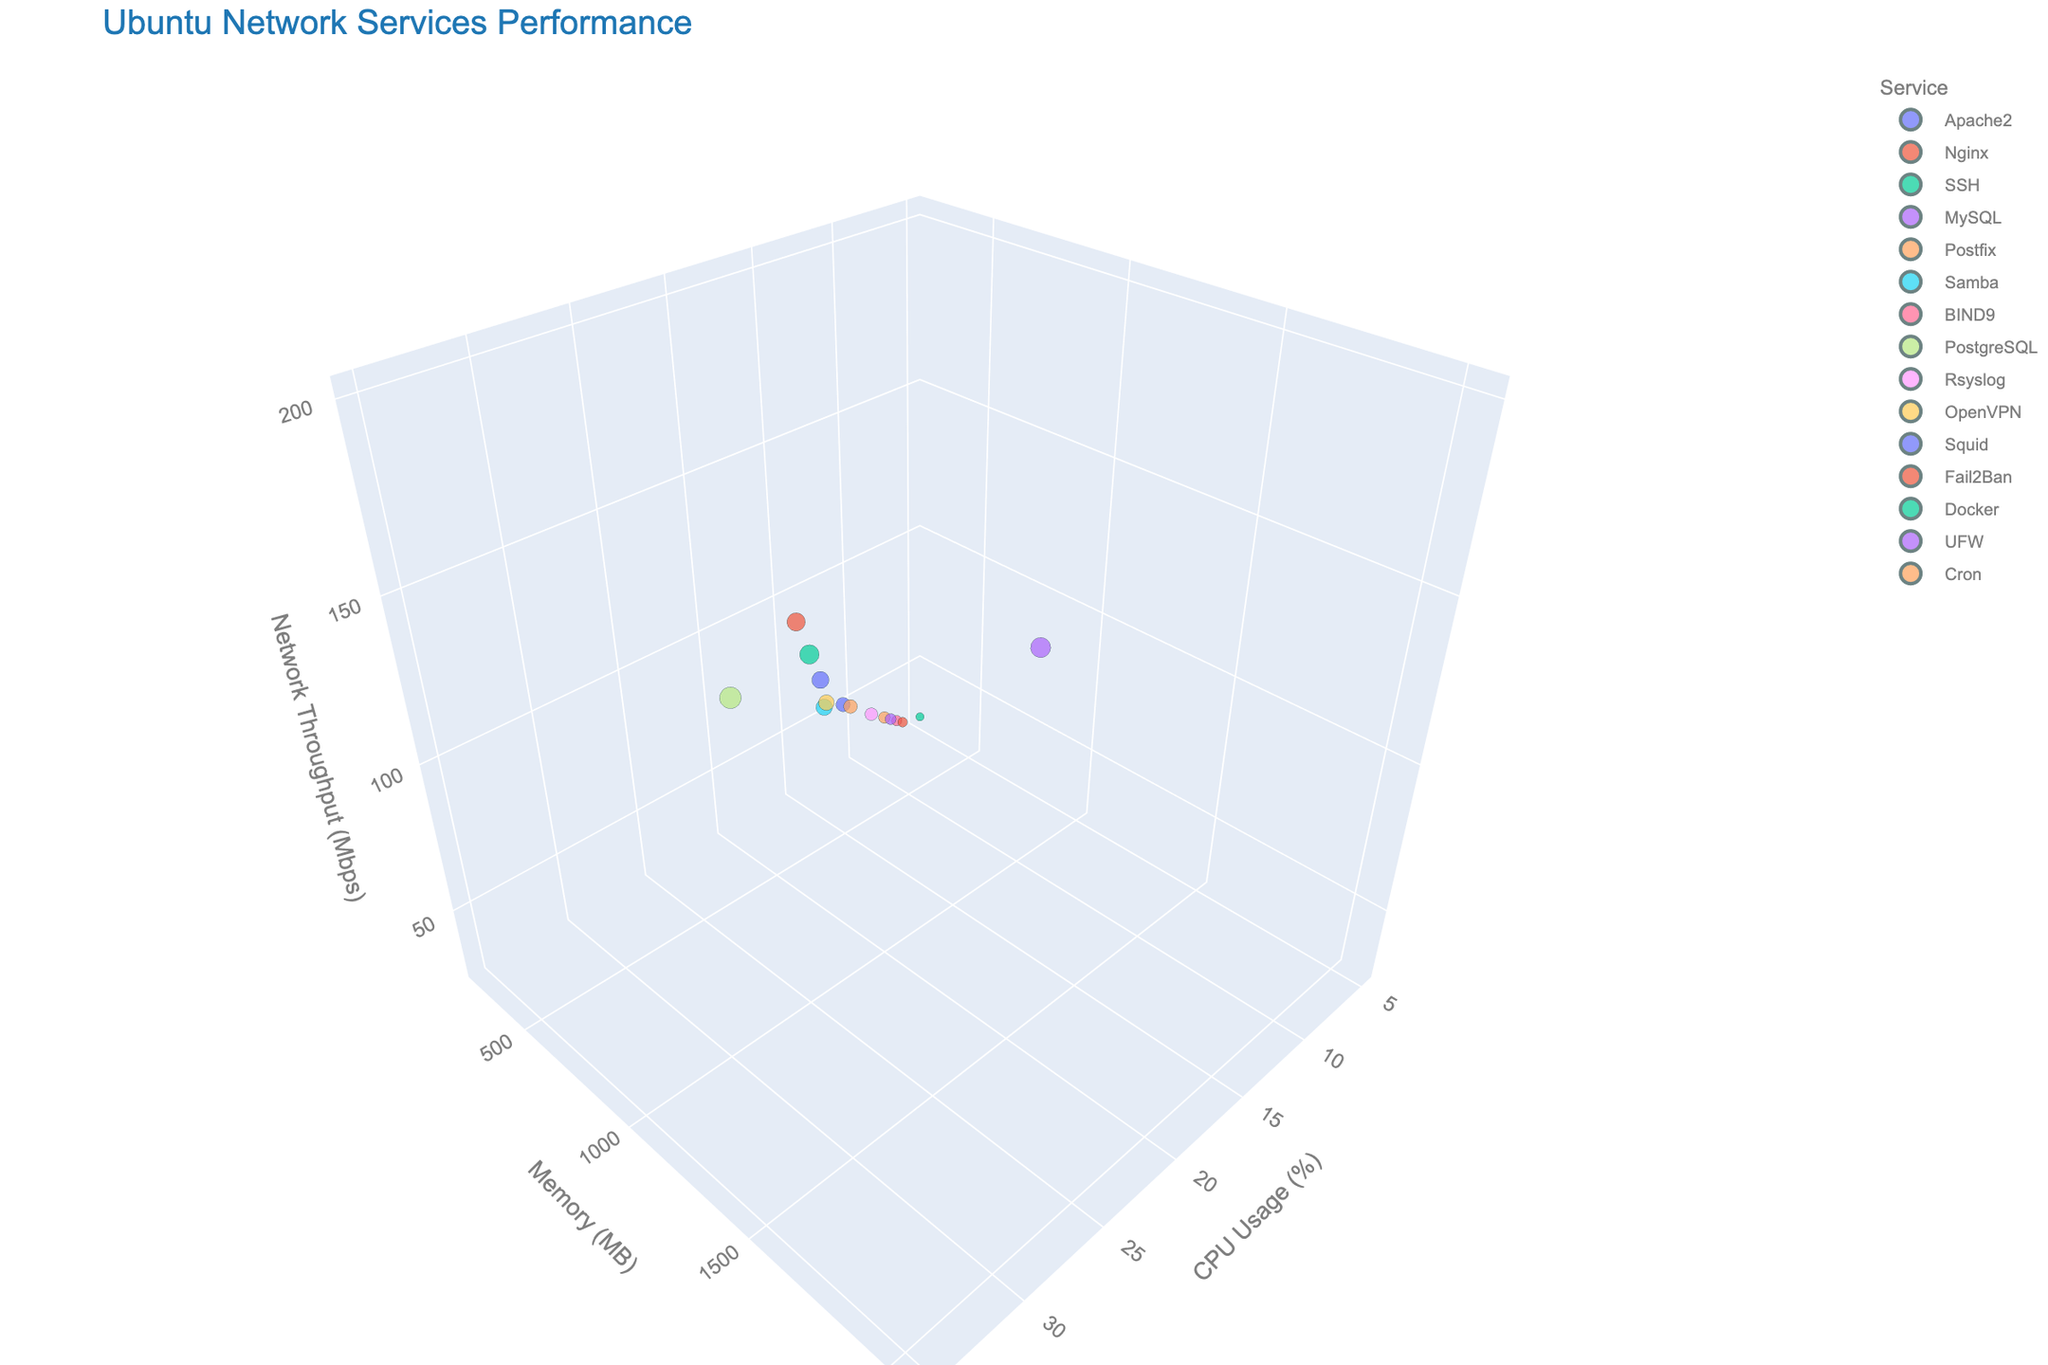How many different services are shown in the plot? By counting each unique service label in the data points, we find there are 15 different services represented in the plot.
Answer: 15 Which service has the highest CPU usage? By looking at the 'CPU Usage' axis, the highest value is 35, and the corresponding service is PostgreSQL.
Answer: PostgreSQL What is the sum of memory consumption for Apache2 and Nginx? Apache2 uses 512 MB and Nginx uses 1024 MB. The sum is 512 + 1024 = 1536 MB.
Answer: 1536 MB Which service has the lowest network throughput? By checking the 'Network Throughput' axis, the lowest value is 30, and the corresponding service is SSH.
Answer: SSH What is the ratio of CPU usage between MySQL and Cron? MySQL has a CPU usage of 30, and Cron has a CPU usage of 14. The ratio is 30 / 14 = 2.14.
Answer: 2.14 Compare the memory consumption between Docker and Squid. Which one uses more? Docker's memory consumption is 1280 MB, whereas Squid's is 896 MB. Docker uses more memory.
Answer: Docker What is the average network throughput of the services whose CPU usage is above 20%? The services with CPU usage above 20% are Nginx (150), MySQL (200), PostgreSQL (180), Docker (160), Squid (120). The average is (150 + 200 + 180 + 160 + 120) / 5 = 162 Mbps.
Answer: 162 Mbps Identify the service with the second highest memory consumption. The highest memory consumption is MySQL (2048 MB), and the second highest is PostgreSQL (1536 MB).
Answer: PostgreSQL Compare the network throughput of Apache2 and UFW. Which one has higher throughput? Apache2's network throughput is 75 Mbps, and UFW's is 45 Mbps. Apache2 has higher throughput.
Answer: Apache2 What is the median CPU usage for all services? Ordering the CPU Usage values: 5, 7, 8, 9, 10, 12, 14, 15, 18, 20, 22, 25, 28, 30, 35. The median value (middle value in an ordered list with 15 elements) is 15.
Answer: 15 